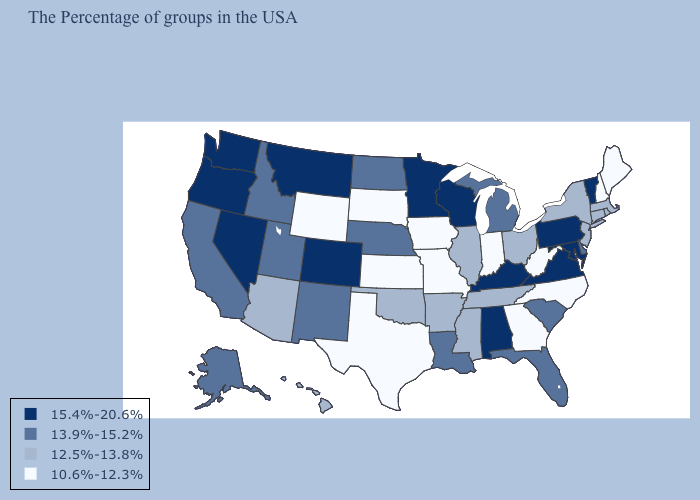What is the value of Colorado?
Short answer required. 15.4%-20.6%. Does Vermont have the highest value in the Northeast?
Be succinct. Yes. Does the map have missing data?
Write a very short answer. No. Name the states that have a value in the range 13.9%-15.2%?
Quick response, please. Delaware, South Carolina, Florida, Michigan, Louisiana, Nebraska, North Dakota, New Mexico, Utah, Idaho, California, Alaska. What is the value of Indiana?
Be succinct. 10.6%-12.3%. Does Maine have the lowest value in the USA?
Be succinct. Yes. What is the value of Ohio?
Keep it brief. 12.5%-13.8%. What is the value of Rhode Island?
Be succinct. 12.5%-13.8%. Does Colorado have the highest value in the USA?
Concise answer only. Yes. Name the states that have a value in the range 10.6%-12.3%?
Be succinct. Maine, New Hampshire, North Carolina, West Virginia, Georgia, Indiana, Missouri, Iowa, Kansas, Texas, South Dakota, Wyoming. Does Iowa have the lowest value in the MidWest?
Be succinct. Yes. What is the value of Oklahoma?
Short answer required. 12.5%-13.8%. Among the states that border Minnesota , does North Dakota have the highest value?
Keep it brief. No. What is the value of Missouri?
Answer briefly. 10.6%-12.3%. Which states have the highest value in the USA?
Short answer required. Vermont, Maryland, Pennsylvania, Virginia, Kentucky, Alabama, Wisconsin, Minnesota, Colorado, Montana, Nevada, Washington, Oregon. 